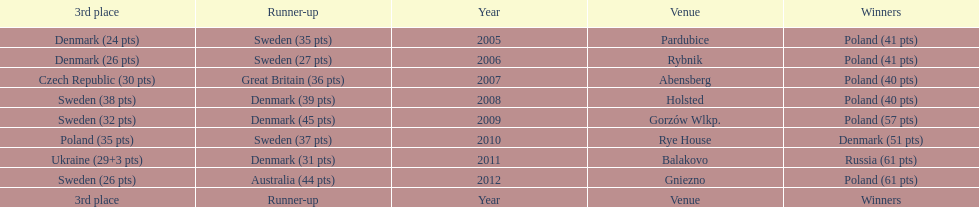Give me the full table as a dictionary. {'header': ['3rd place', 'Runner-up', 'Year', 'Venue', 'Winners'], 'rows': [['Denmark (24 pts)', 'Sweden (35 pts)', '2005', 'Pardubice', 'Poland (41 pts)'], ['Denmark (26 pts)', 'Sweden (27 pts)', '2006', 'Rybnik', 'Poland (41 pts)'], ['Czech Republic (30 pts)', 'Great Britain (36 pts)', '2007', 'Abensberg', 'Poland (40 pts)'], ['Sweden (38 pts)', 'Denmark (39 pts)', '2008', 'Holsted', 'Poland (40 pts)'], ['Sweden (32 pts)', 'Denmark (45 pts)', '2009', 'Gorzów Wlkp.', 'Poland (57 pts)'], ['Poland (35 pts)', 'Sweden (37 pts)', '2010', 'Rye House', 'Denmark (51 pts)'], ['Ukraine (29+3 pts)', 'Denmark (31 pts)', '2011', 'Balakovo', 'Russia (61 pts)'], ['Sweden (26 pts)', 'Australia (44 pts)', '2012', 'Gniezno', 'Poland (61 pts)'], ['3rd place', 'Runner-up', 'Year', 'Venue', 'Winners']]} After 2008 how many points total were scored by winners? 230. 